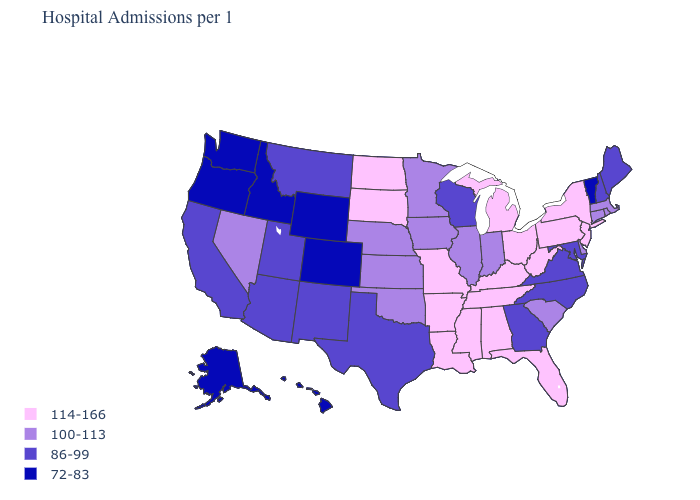Name the states that have a value in the range 100-113?
Quick response, please. Connecticut, Delaware, Illinois, Indiana, Iowa, Kansas, Massachusetts, Minnesota, Nebraska, Nevada, Oklahoma, Rhode Island, South Carolina. Name the states that have a value in the range 86-99?
Concise answer only. Arizona, California, Georgia, Maine, Maryland, Montana, New Hampshire, New Mexico, North Carolina, Texas, Utah, Virginia, Wisconsin. Among the states that border Montana , which have the highest value?
Concise answer only. North Dakota, South Dakota. Which states have the lowest value in the MidWest?
Answer briefly. Wisconsin. What is the lowest value in states that border New Mexico?
Keep it brief. 72-83. What is the highest value in states that border New Mexico?
Short answer required. 100-113. Is the legend a continuous bar?
Give a very brief answer. No. What is the lowest value in the South?
Keep it brief. 86-99. Does Nebraska have the highest value in the MidWest?
Concise answer only. No. What is the value of Louisiana?
Concise answer only. 114-166. Does North Carolina have the same value as New Mexico?
Be succinct. Yes. Which states have the highest value in the USA?
Give a very brief answer. Alabama, Arkansas, Florida, Kentucky, Louisiana, Michigan, Mississippi, Missouri, New Jersey, New York, North Dakota, Ohio, Pennsylvania, South Dakota, Tennessee, West Virginia. Which states have the lowest value in the USA?
Write a very short answer. Alaska, Colorado, Hawaii, Idaho, Oregon, Vermont, Washington, Wyoming. Does Virginia have the lowest value in the USA?
Be succinct. No. What is the value of Michigan?
Give a very brief answer. 114-166. 